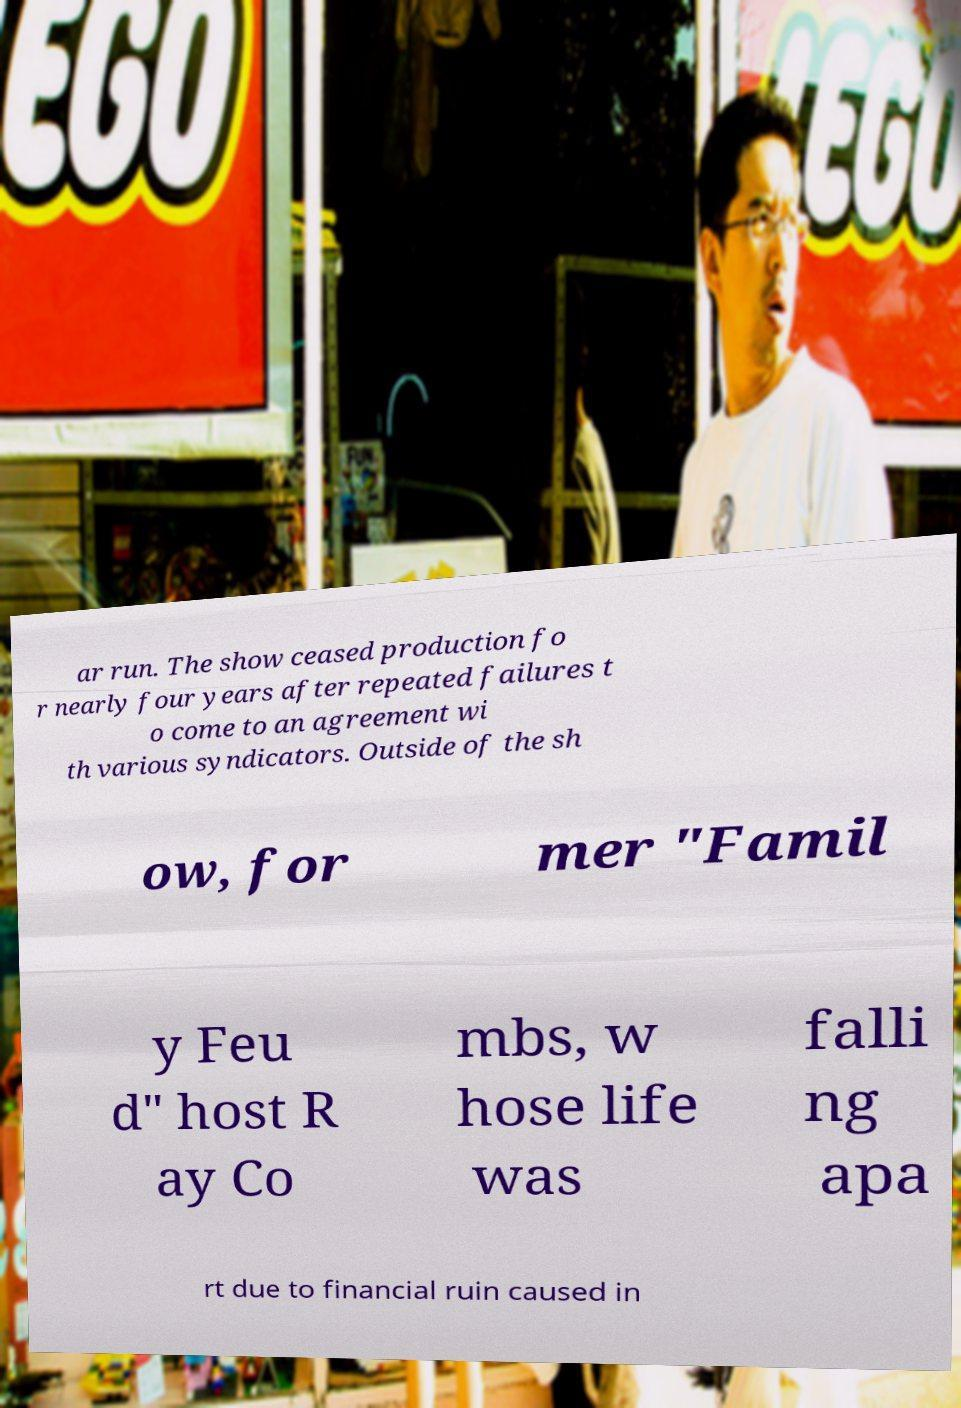Could you extract and type out the text from this image? ar run. The show ceased production fo r nearly four years after repeated failures t o come to an agreement wi th various syndicators. Outside of the sh ow, for mer "Famil y Feu d" host R ay Co mbs, w hose life was falli ng apa rt due to financial ruin caused in 